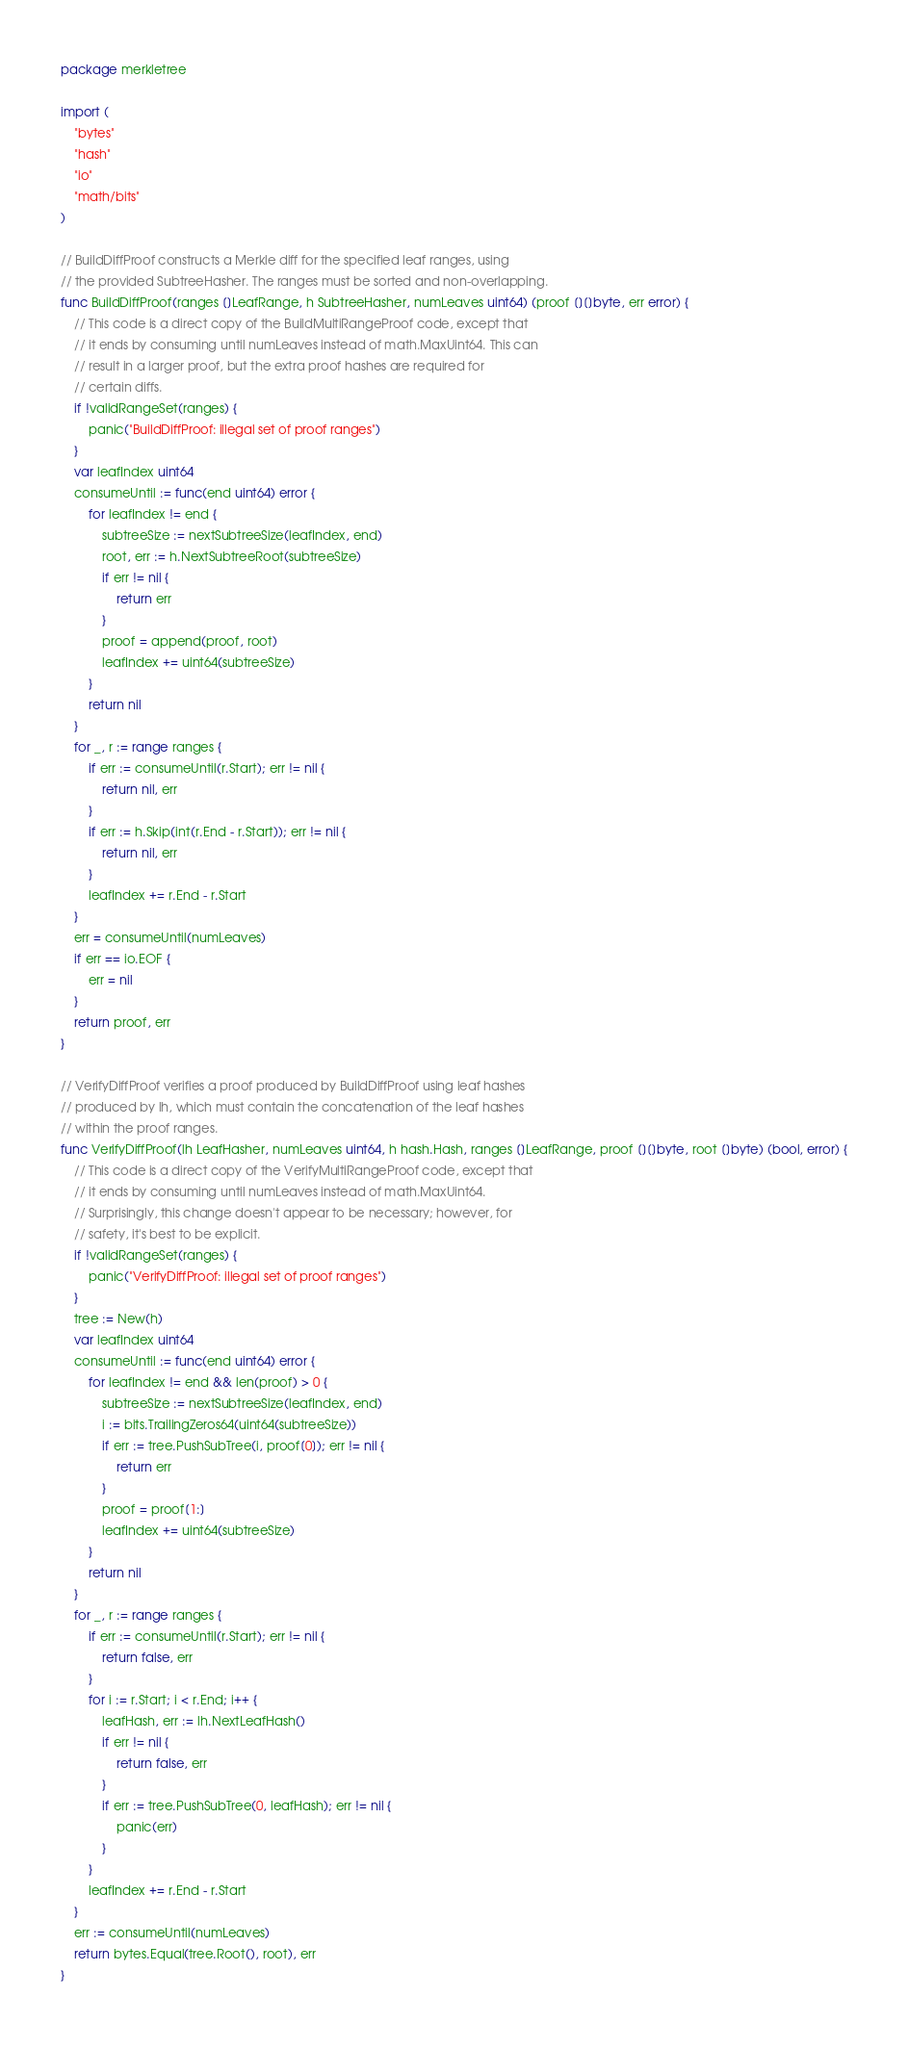<code> <loc_0><loc_0><loc_500><loc_500><_Go_>package merkletree

import (
	"bytes"
	"hash"
	"io"
	"math/bits"
)

// BuildDiffProof constructs a Merkle diff for the specified leaf ranges, using
// the provided SubtreeHasher. The ranges must be sorted and non-overlapping.
func BuildDiffProof(ranges []LeafRange, h SubtreeHasher, numLeaves uint64) (proof [][]byte, err error) {
	// This code is a direct copy of the BuildMultiRangeProof code, except that
	// it ends by consuming until numLeaves instead of math.MaxUint64. This can
	// result in a larger proof, but the extra proof hashes are required for
	// certain diffs.
	if !validRangeSet(ranges) {
		panic("BuildDiffProof: illegal set of proof ranges")
	}
	var leafIndex uint64
	consumeUntil := func(end uint64) error {
		for leafIndex != end {
			subtreeSize := nextSubtreeSize(leafIndex, end)
			root, err := h.NextSubtreeRoot(subtreeSize)
			if err != nil {
				return err
			}
			proof = append(proof, root)
			leafIndex += uint64(subtreeSize)
		}
		return nil
	}
	for _, r := range ranges {
		if err := consumeUntil(r.Start); err != nil {
			return nil, err
		}
		if err := h.Skip(int(r.End - r.Start)); err != nil {
			return nil, err
		}
		leafIndex += r.End - r.Start
	}
	err = consumeUntil(numLeaves)
	if err == io.EOF {
		err = nil
	}
	return proof, err
}

// VerifyDiffProof verifies a proof produced by BuildDiffProof using leaf hashes
// produced by lh, which must contain the concatenation of the leaf hashes
// within the proof ranges.
func VerifyDiffProof(lh LeafHasher, numLeaves uint64, h hash.Hash, ranges []LeafRange, proof [][]byte, root []byte) (bool, error) {
	// This code is a direct copy of the VerifyMultiRangeProof code, except that
	// it ends by consuming until numLeaves instead of math.MaxUint64.
	// Surprisingly, this change doesn't appear to be necessary; however, for
	// safety, it's best to be explicit.
	if !validRangeSet(ranges) {
		panic("VerifyDiffProof: illegal set of proof ranges")
	}
	tree := New(h)
	var leafIndex uint64
	consumeUntil := func(end uint64) error {
		for leafIndex != end && len(proof) > 0 {
			subtreeSize := nextSubtreeSize(leafIndex, end)
			i := bits.TrailingZeros64(uint64(subtreeSize))
			if err := tree.PushSubTree(i, proof[0]); err != nil {
				return err
			}
			proof = proof[1:]
			leafIndex += uint64(subtreeSize)
		}
		return nil
	}
	for _, r := range ranges {
		if err := consumeUntil(r.Start); err != nil {
			return false, err
		}
		for i := r.Start; i < r.End; i++ {
			leafHash, err := lh.NextLeafHash()
			if err != nil {
				return false, err
			}
			if err := tree.PushSubTree(0, leafHash); err != nil {
				panic(err)
			}
		}
		leafIndex += r.End - r.Start
	}
	err := consumeUntil(numLeaves)
	return bytes.Equal(tree.Root(), root), err
}
</code> 